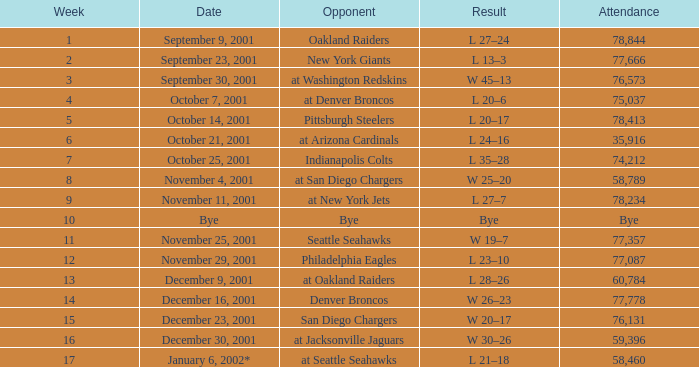How many attended the game on December 16, 2001? 77778.0. 